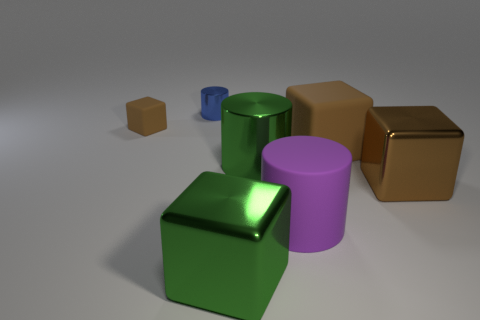What shape is the brown rubber thing right of the brown block that is left of the big rubber cylinder?
Give a very brief answer. Cube. There is a cylinder that is behind the large purple matte cylinder and in front of the tiny blue object; what is its size?
Your response must be concise. Large. Is there another big object of the same shape as the purple rubber thing?
Your answer should be very brief. Yes. What material is the tiny thing to the right of the brown cube that is to the left of the big metal cube that is on the left side of the brown metal cube?
Provide a succinct answer. Metal. Is there a green shiny object of the same size as the brown metal thing?
Your answer should be very brief. Yes. What color is the metal cylinder that is left of the big block to the left of the green metal cylinder?
Keep it short and to the point. Blue. What number of big purple matte spheres are there?
Your response must be concise. 0. Does the small rubber thing have the same color as the large rubber block?
Provide a succinct answer. Yes. Is the number of green cylinders in front of the green cylinder less than the number of brown metallic things behind the small brown matte thing?
Provide a succinct answer. No. The tiny metallic cylinder has what color?
Your answer should be very brief. Blue. 